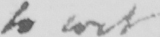Can you read and transcribe this handwriting? to wit 